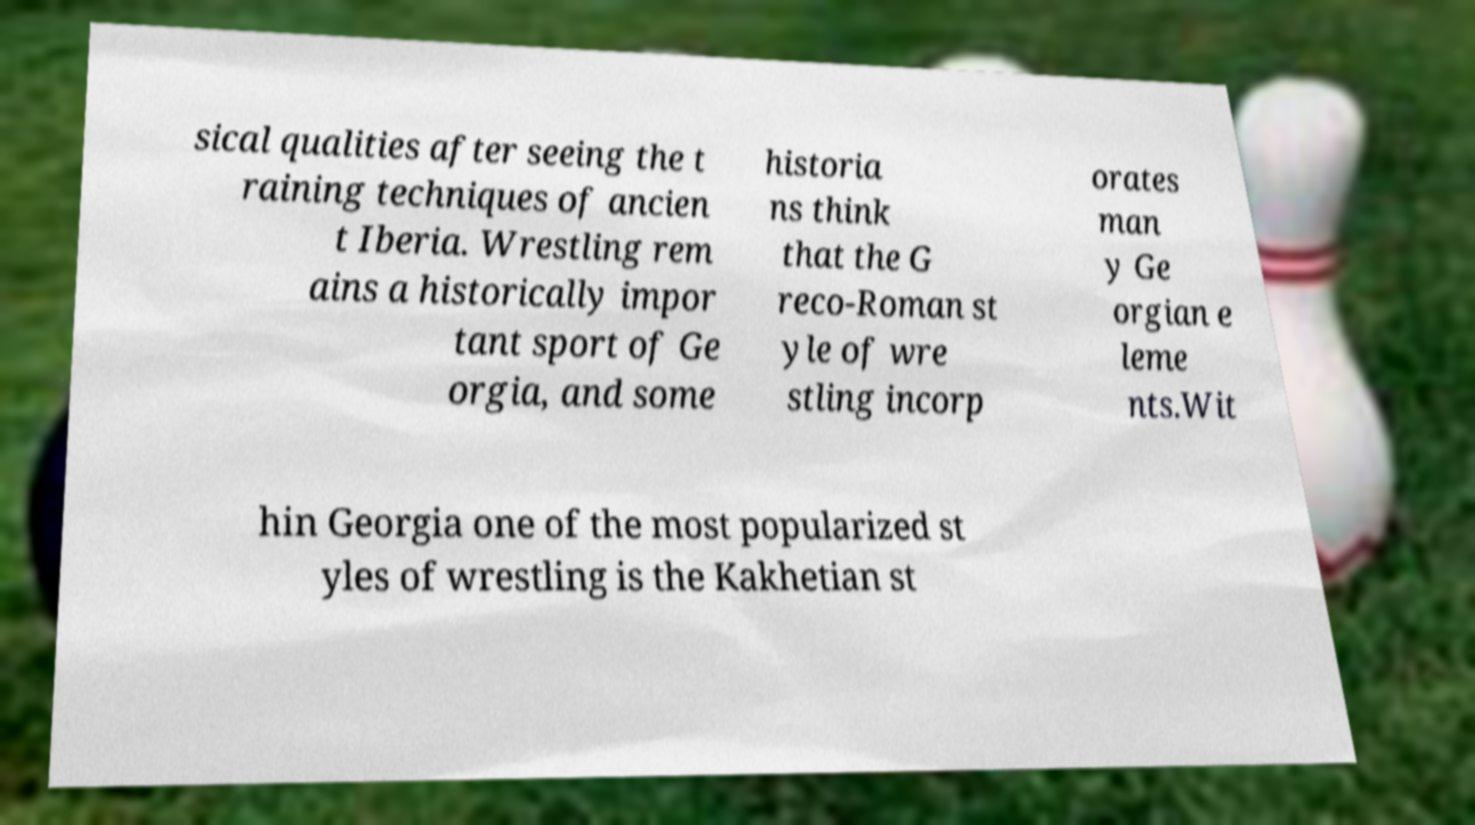Please identify and transcribe the text found in this image. sical qualities after seeing the t raining techniques of ancien t Iberia. Wrestling rem ains a historically impor tant sport of Ge orgia, and some historia ns think that the G reco-Roman st yle of wre stling incorp orates man y Ge orgian e leme nts.Wit hin Georgia one of the most popularized st yles of wrestling is the Kakhetian st 